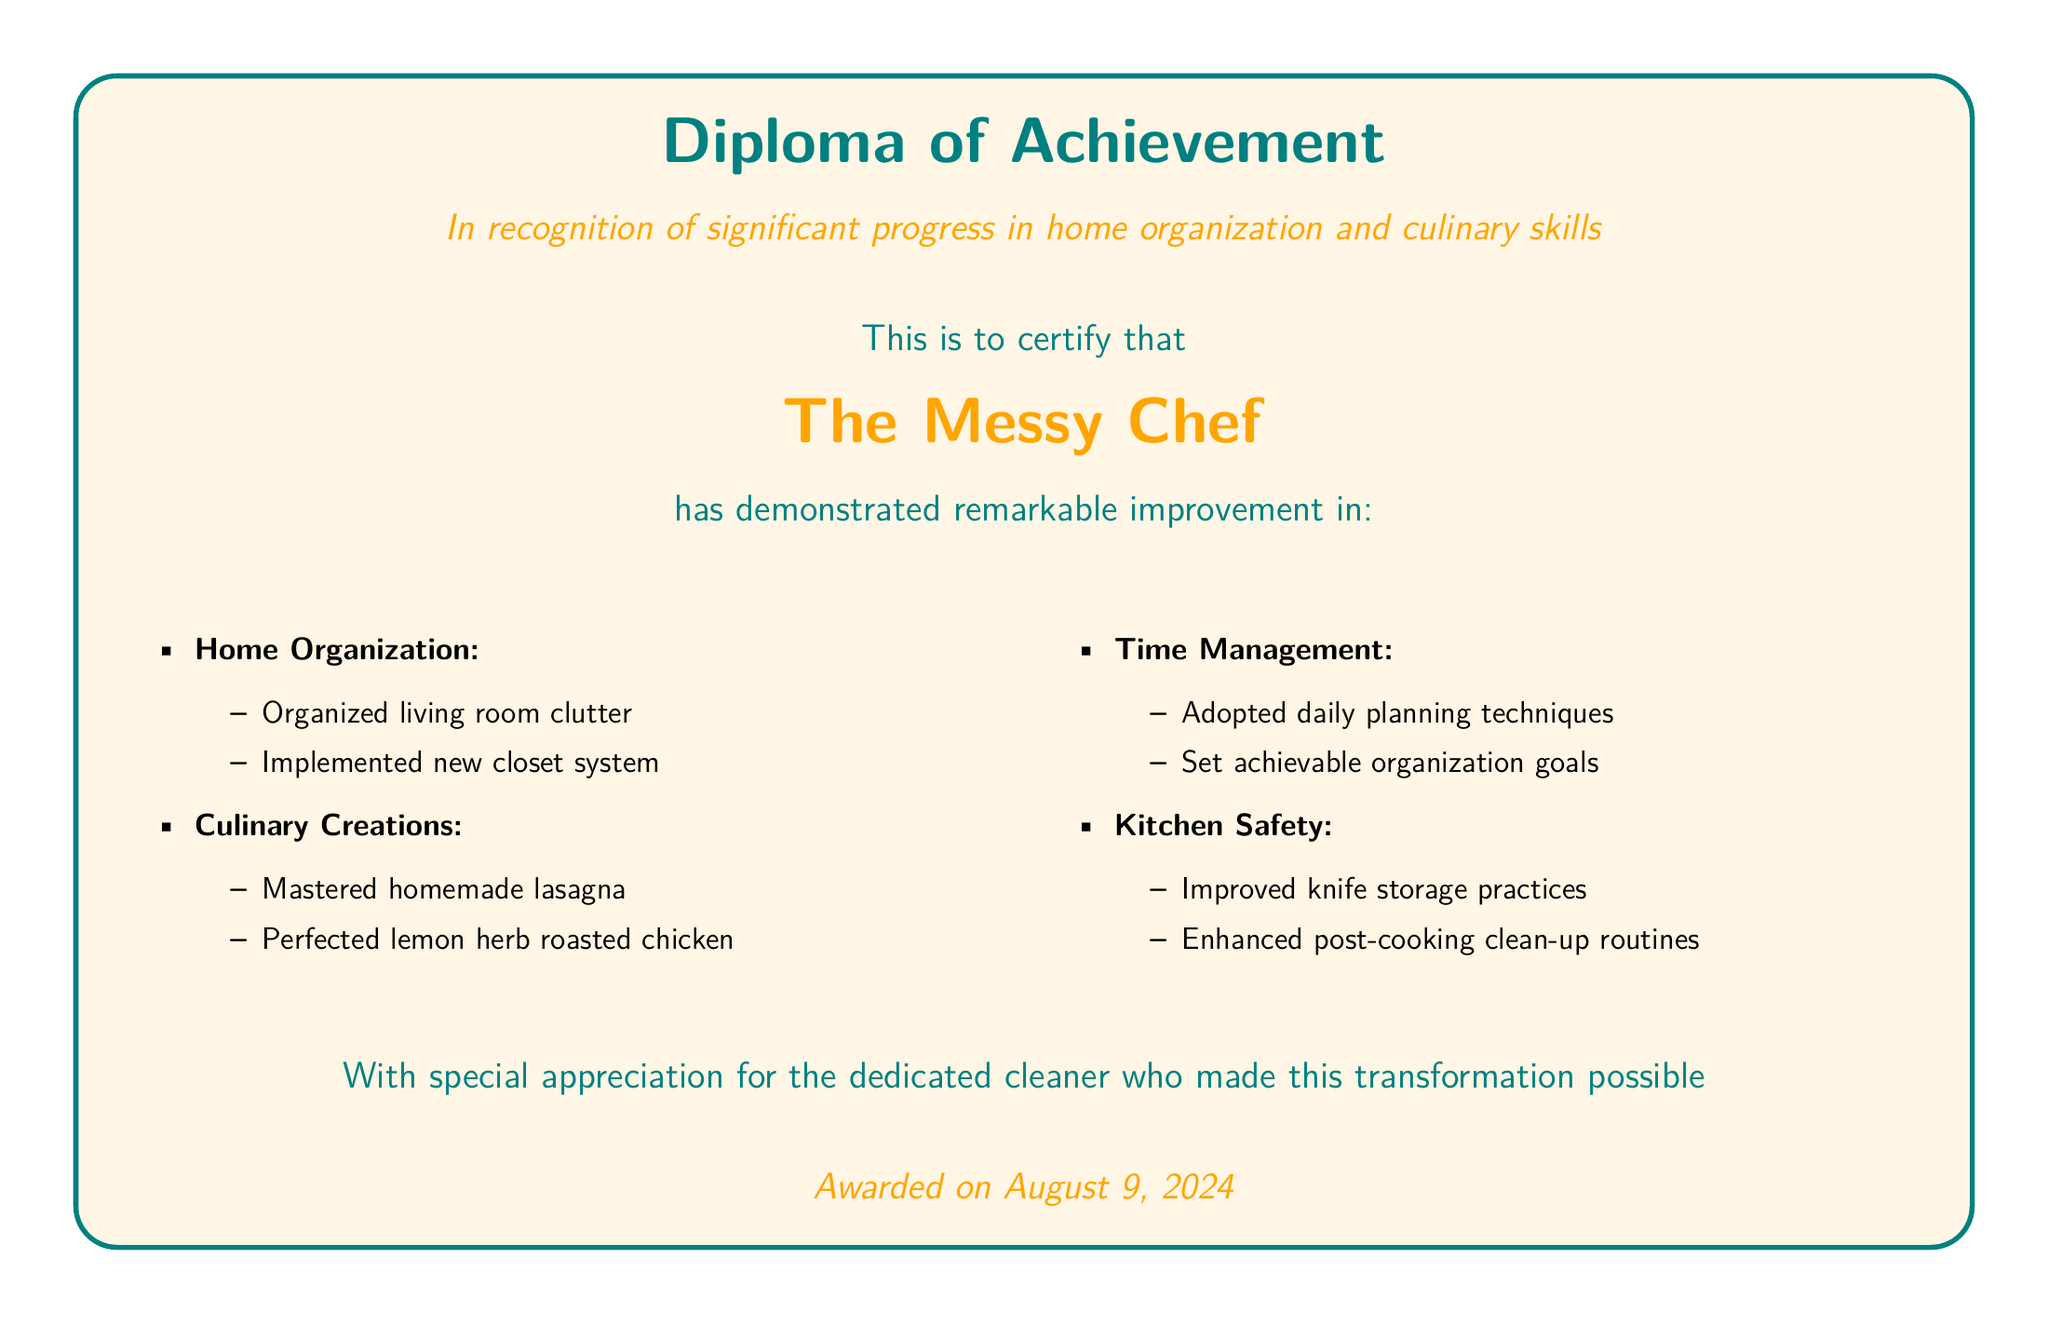What is the title of the diploma? The title of the diploma is prominently displayed at the top of the document, stating it is a "Diploma of Achievement."
Answer: Diploma of Achievement Who is the certificate awarded to? The diploma certifies an individual recognized for their achievements, specifically mentioning "The Messy Chef."
Answer: The Messy Chef What date was the diploma awarded? The document specifies that the award date is marked as "on today," which refers to the current date of issuance.
Answer: today How many main improvement areas are listed in the document? The diploma lists four main areas of improvement achieved by the recipient, which are organized in bullet points.
Answer: 4 What culinary dish is mentioned as being mastered? The document details two culinary creations, one of which is "homemade lasagna."
Answer: homemade lasagna What home organization system was implemented? The diploma indicates that a new "closet system" was implemented as part of the organizational improvements made.
Answer: closet system What safety practice was enhanced in the kitchen? The document mentions that "post-cooking clean-up routines" were enhanced, contributing to kitchen safety.
Answer: post-cooking clean-up routines Who is appreciated for the transformation mentioned in the diploma? The document includes a statement expressing appreciation for the "dedicated cleaner" who facilitated the transformations.
Answer: dedicated cleaner 